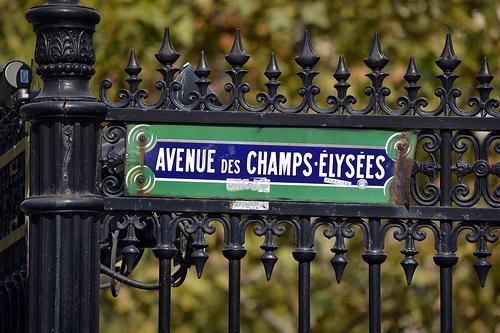How many people are there?
Give a very brief answer. 0. 